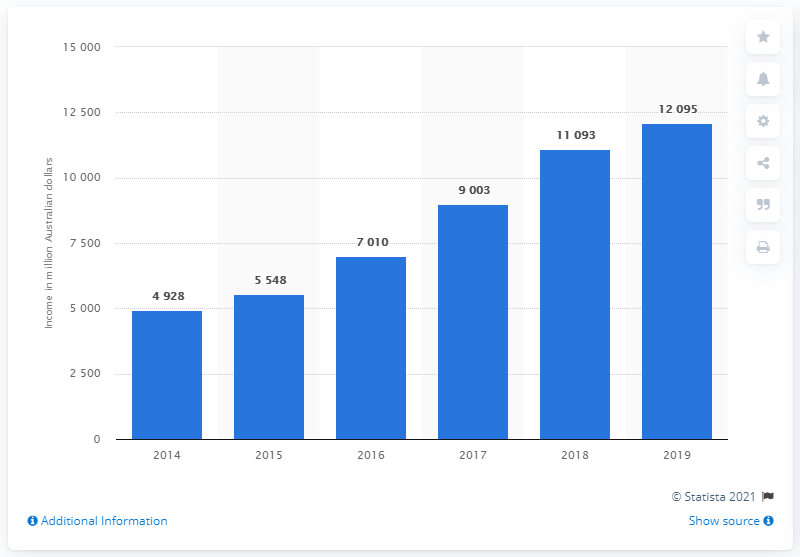Indicate a few pertinent items in this graphic. The education income received from Chinese students in Australia in the financial year 2019 was valued at $120,950. 